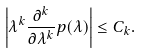Convert formula to latex. <formula><loc_0><loc_0><loc_500><loc_500>\left | \lambda ^ { k } \frac { \partial ^ { k } } { \partial \lambda ^ { k } } p ( \lambda ) \right | \leq C _ { k } .</formula> 